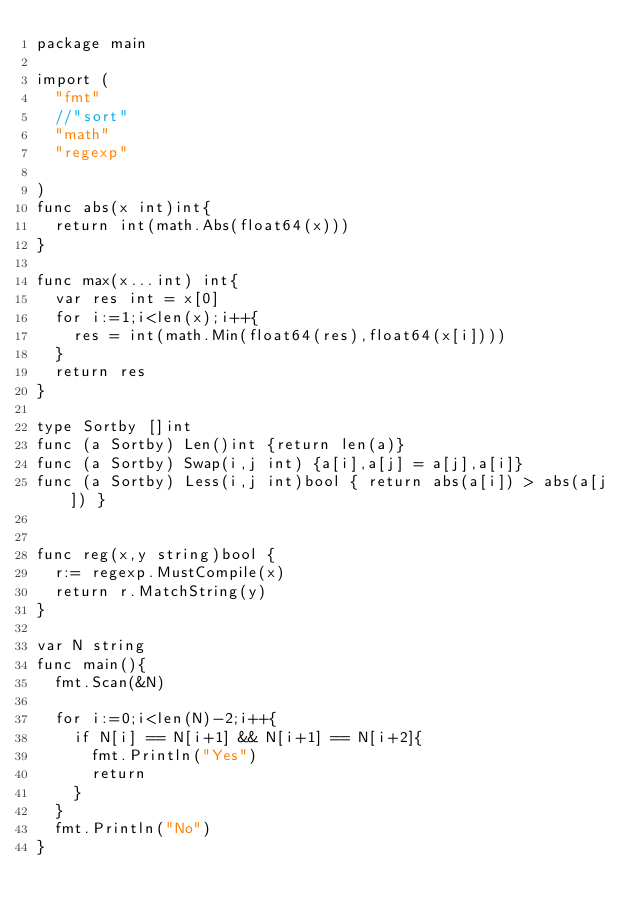<code> <loc_0><loc_0><loc_500><loc_500><_Go_>package main

import (
	"fmt"
	//"sort"
	"math"
	"regexp"

)
func abs(x int)int{
	return int(math.Abs(float64(x)))
}

func max(x...int) int{
	var res int = x[0]
	for i:=1;i<len(x);i++{
		res = int(math.Min(float64(res),float64(x[i])))
	}
	return res
}

type Sortby []int
func (a Sortby) Len()int {return len(a)}
func (a Sortby) Swap(i,j int) {a[i],a[j] = a[j],a[i]}
func (a Sortby) Less(i,j int)bool { return abs(a[i]) > abs(a[j]) }


func reg(x,y string)bool {
	r:= regexp.MustCompile(x)
	return r.MatchString(y)
}

var N string
func main(){
	fmt.Scan(&N)
	
	for i:=0;i<len(N)-2;i++{
		if N[i] == N[i+1] && N[i+1] == N[i+2]{
			fmt.Println("Yes")
			return
		}
	}
	fmt.Println("No")
}</code> 